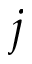Convert formula to latex. <formula><loc_0><loc_0><loc_500><loc_500>j</formula> 